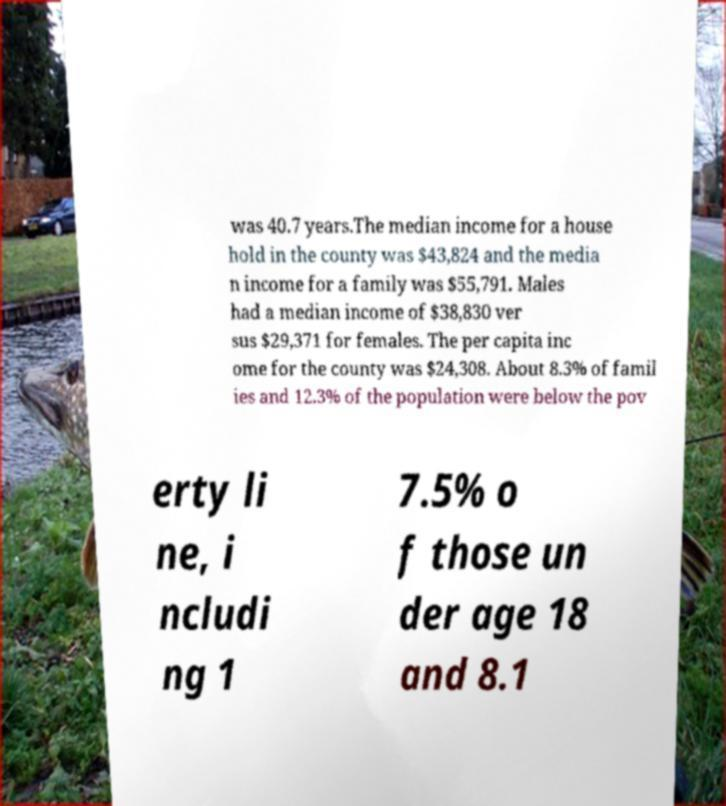Can you accurately transcribe the text from the provided image for me? was 40.7 years.The median income for a house hold in the county was $43,824 and the media n income for a family was $55,791. Males had a median income of $38,830 ver sus $29,371 for females. The per capita inc ome for the county was $24,308. About 8.3% of famil ies and 12.3% of the population were below the pov erty li ne, i ncludi ng 1 7.5% o f those un der age 18 and 8.1 